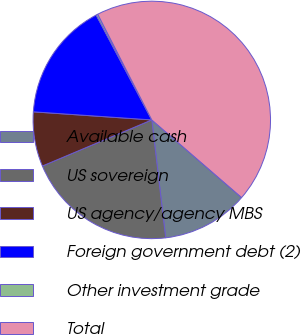Convert chart to OTSL. <chart><loc_0><loc_0><loc_500><loc_500><pie_chart><fcel>Available cash<fcel>US sovereign<fcel>US agency/agency MBS<fcel>Foreign government debt (2)<fcel>Other investment grade<fcel>Total<nl><fcel>11.79%<fcel>20.52%<fcel>7.43%<fcel>16.15%<fcel>0.24%<fcel>43.87%<nl></chart> 